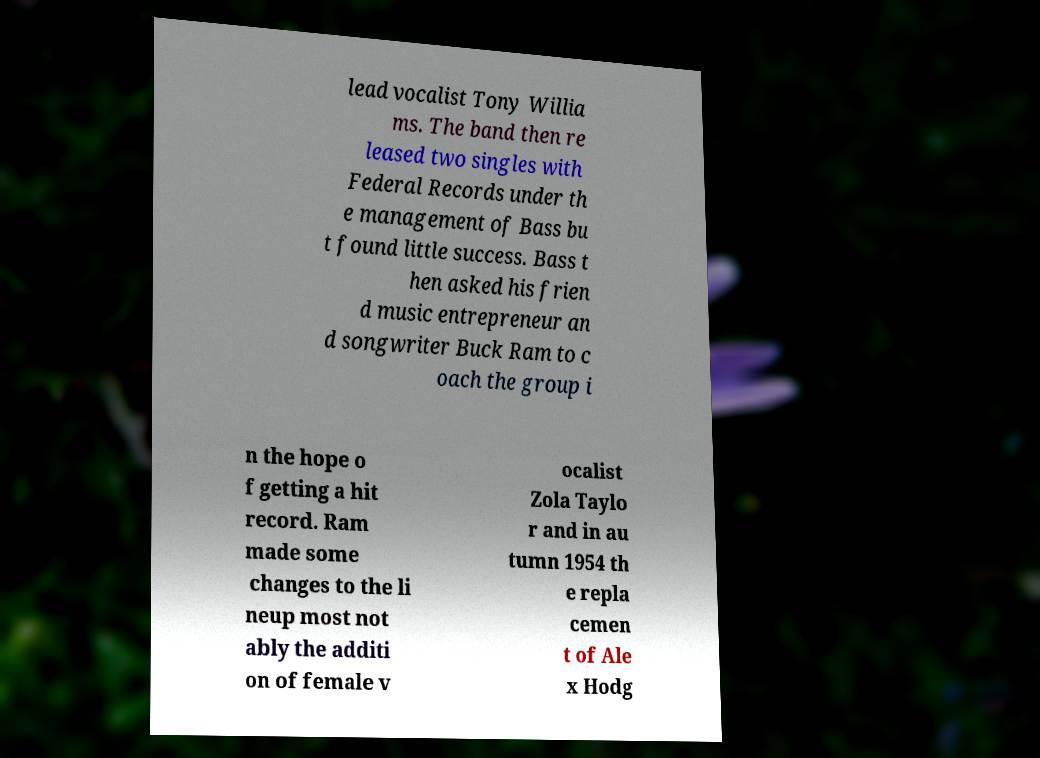Could you extract and type out the text from this image? lead vocalist Tony Willia ms. The band then re leased two singles with Federal Records under th e management of Bass bu t found little success. Bass t hen asked his frien d music entrepreneur an d songwriter Buck Ram to c oach the group i n the hope o f getting a hit record. Ram made some changes to the li neup most not ably the additi on of female v ocalist Zola Taylo r and in au tumn 1954 th e repla cemen t of Ale x Hodg 